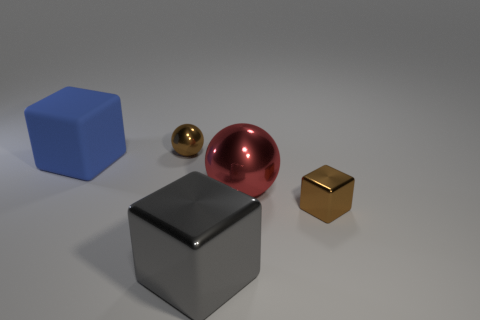There is a big object that is on the left side of the red thing and in front of the rubber object; what is its color?
Your response must be concise. Gray. Do the brown thing behind the red metallic sphere and the small metal block have the same size?
Provide a short and direct response. Yes. Are there any other things that have the same shape as the large matte thing?
Offer a terse response. Yes. Are the blue thing and the ball that is in front of the blue cube made of the same material?
Your answer should be very brief. No. How many yellow things are either small spheres or shiny things?
Your answer should be very brief. 0. Are any small brown spheres visible?
Provide a short and direct response. Yes. There is a small brown object behind the big cube on the left side of the tiny ball; is there a tiny brown sphere behind it?
Make the answer very short. No. Is there anything else that has the same size as the gray block?
Make the answer very short. Yes. There is a big blue thing; does it have the same shape as the brown metal object that is in front of the big blue matte thing?
Keep it short and to the point. Yes. What color is the small block that is in front of the brown metallic object that is on the left side of the sphere in front of the big matte block?
Your response must be concise. Brown. 